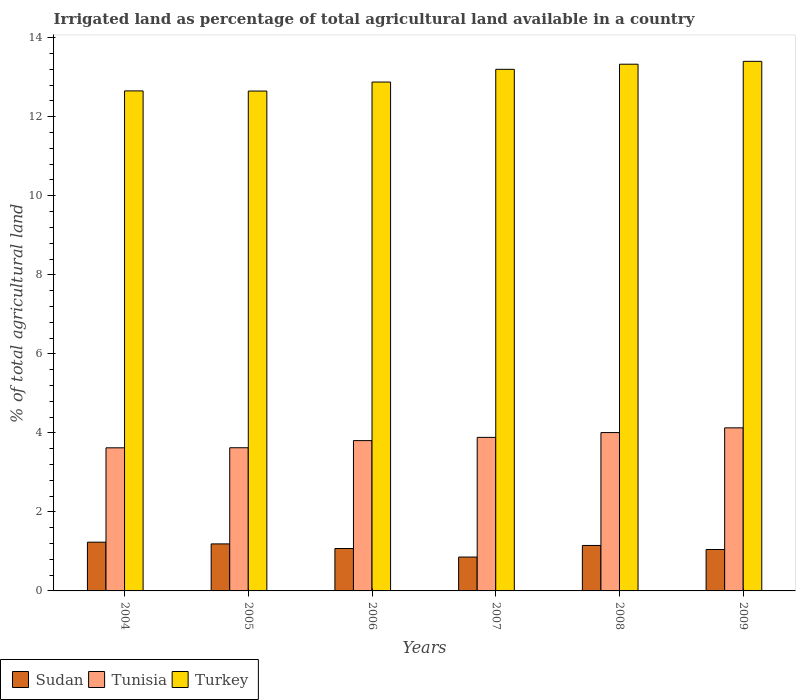How many groups of bars are there?
Give a very brief answer. 6. Are the number of bars per tick equal to the number of legend labels?
Your answer should be very brief. Yes. Are the number of bars on each tick of the X-axis equal?
Your answer should be very brief. Yes. How many bars are there on the 4th tick from the right?
Your answer should be compact. 3. What is the percentage of irrigated land in Tunisia in 2007?
Make the answer very short. 3.89. Across all years, what is the maximum percentage of irrigated land in Tunisia?
Provide a succinct answer. 4.13. Across all years, what is the minimum percentage of irrigated land in Tunisia?
Make the answer very short. 3.62. In which year was the percentage of irrigated land in Turkey maximum?
Ensure brevity in your answer.  2009. In which year was the percentage of irrigated land in Tunisia minimum?
Make the answer very short. 2004. What is the total percentage of irrigated land in Turkey in the graph?
Make the answer very short. 78.12. What is the difference between the percentage of irrigated land in Turkey in 2004 and that in 2007?
Give a very brief answer. -0.55. What is the difference between the percentage of irrigated land in Turkey in 2009 and the percentage of irrigated land in Sudan in 2006?
Keep it short and to the point. 12.33. What is the average percentage of irrigated land in Sudan per year?
Provide a short and direct response. 1.09. In the year 2006, what is the difference between the percentage of irrigated land in Turkey and percentage of irrigated land in Tunisia?
Give a very brief answer. 9.07. What is the ratio of the percentage of irrigated land in Turkey in 2005 to that in 2006?
Make the answer very short. 0.98. What is the difference between the highest and the second highest percentage of irrigated land in Tunisia?
Offer a terse response. 0.12. What is the difference between the highest and the lowest percentage of irrigated land in Tunisia?
Keep it short and to the point. 0.51. What does the 1st bar from the left in 2007 represents?
Give a very brief answer. Sudan. What does the 3rd bar from the right in 2004 represents?
Keep it short and to the point. Sudan. Is it the case that in every year, the sum of the percentage of irrigated land in Tunisia and percentage of irrigated land in Sudan is greater than the percentage of irrigated land in Turkey?
Your answer should be very brief. No. Are all the bars in the graph horizontal?
Give a very brief answer. No. How many years are there in the graph?
Give a very brief answer. 6. What is the difference between two consecutive major ticks on the Y-axis?
Keep it short and to the point. 2. Does the graph contain grids?
Provide a short and direct response. No. Where does the legend appear in the graph?
Keep it short and to the point. Bottom left. How many legend labels are there?
Ensure brevity in your answer.  3. How are the legend labels stacked?
Provide a succinct answer. Horizontal. What is the title of the graph?
Ensure brevity in your answer.  Irrigated land as percentage of total agricultural land available in a country. Does "Iraq" appear as one of the legend labels in the graph?
Offer a terse response. No. What is the label or title of the Y-axis?
Your response must be concise. % of total agricultural land. What is the % of total agricultural land in Sudan in 2004?
Ensure brevity in your answer.  1.23. What is the % of total agricultural land of Tunisia in 2004?
Keep it short and to the point. 3.62. What is the % of total agricultural land of Turkey in 2004?
Your answer should be compact. 12.65. What is the % of total agricultural land in Sudan in 2005?
Offer a very short reply. 1.19. What is the % of total agricultural land of Tunisia in 2005?
Your response must be concise. 3.62. What is the % of total agricultural land of Turkey in 2005?
Make the answer very short. 12.65. What is the % of total agricultural land of Sudan in 2006?
Keep it short and to the point. 1.07. What is the % of total agricultural land in Tunisia in 2006?
Your response must be concise. 3.8. What is the % of total agricultural land in Turkey in 2006?
Offer a very short reply. 12.88. What is the % of total agricultural land in Sudan in 2007?
Offer a very short reply. 0.86. What is the % of total agricultural land in Tunisia in 2007?
Your answer should be compact. 3.89. What is the % of total agricultural land in Turkey in 2007?
Your answer should be compact. 13.2. What is the % of total agricultural land in Sudan in 2008?
Your answer should be compact. 1.15. What is the % of total agricultural land of Tunisia in 2008?
Keep it short and to the point. 4.01. What is the % of total agricultural land in Turkey in 2008?
Provide a short and direct response. 13.33. What is the % of total agricultural land in Sudan in 2009?
Your response must be concise. 1.05. What is the % of total agricultural land of Tunisia in 2009?
Ensure brevity in your answer.  4.13. What is the % of total agricultural land of Turkey in 2009?
Offer a very short reply. 13.4. Across all years, what is the maximum % of total agricultural land in Sudan?
Your response must be concise. 1.23. Across all years, what is the maximum % of total agricultural land of Tunisia?
Keep it short and to the point. 4.13. Across all years, what is the maximum % of total agricultural land in Turkey?
Your answer should be very brief. 13.4. Across all years, what is the minimum % of total agricultural land in Sudan?
Provide a short and direct response. 0.86. Across all years, what is the minimum % of total agricultural land in Tunisia?
Make the answer very short. 3.62. Across all years, what is the minimum % of total agricultural land in Turkey?
Your response must be concise. 12.65. What is the total % of total agricultural land in Sudan in the graph?
Ensure brevity in your answer.  6.55. What is the total % of total agricultural land of Tunisia in the graph?
Give a very brief answer. 23.07. What is the total % of total agricultural land of Turkey in the graph?
Your answer should be compact. 78.12. What is the difference between the % of total agricultural land of Sudan in 2004 and that in 2005?
Your answer should be compact. 0.04. What is the difference between the % of total agricultural land in Tunisia in 2004 and that in 2005?
Make the answer very short. -0. What is the difference between the % of total agricultural land of Turkey in 2004 and that in 2005?
Offer a very short reply. 0. What is the difference between the % of total agricultural land in Sudan in 2004 and that in 2006?
Give a very brief answer. 0.16. What is the difference between the % of total agricultural land of Tunisia in 2004 and that in 2006?
Provide a succinct answer. -0.18. What is the difference between the % of total agricultural land of Turkey in 2004 and that in 2006?
Your response must be concise. -0.22. What is the difference between the % of total agricultural land in Sudan in 2004 and that in 2007?
Your answer should be compact. 0.38. What is the difference between the % of total agricultural land in Tunisia in 2004 and that in 2007?
Offer a very short reply. -0.26. What is the difference between the % of total agricultural land of Turkey in 2004 and that in 2007?
Provide a succinct answer. -0.55. What is the difference between the % of total agricultural land in Sudan in 2004 and that in 2008?
Make the answer very short. 0.08. What is the difference between the % of total agricultural land in Tunisia in 2004 and that in 2008?
Your answer should be very brief. -0.39. What is the difference between the % of total agricultural land of Turkey in 2004 and that in 2008?
Your answer should be compact. -0.68. What is the difference between the % of total agricultural land of Sudan in 2004 and that in 2009?
Give a very brief answer. 0.19. What is the difference between the % of total agricultural land in Tunisia in 2004 and that in 2009?
Make the answer very short. -0.51. What is the difference between the % of total agricultural land of Turkey in 2004 and that in 2009?
Your answer should be very brief. -0.75. What is the difference between the % of total agricultural land in Sudan in 2005 and that in 2006?
Your response must be concise. 0.12. What is the difference between the % of total agricultural land of Tunisia in 2005 and that in 2006?
Keep it short and to the point. -0.18. What is the difference between the % of total agricultural land of Turkey in 2005 and that in 2006?
Your answer should be compact. -0.23. What is the difference between the % of total agricultural land of Sudan in 2005 and that in 2007?
Your response must be concise. 0.33. What is the difference between the % of total agricultural land of Tunisia in 2005 and that in 2007?
Offer a terse response. -0.26. What is the difference between the % of total agricultural land in Turkey in 2005 and that in 2007?
Provide a short and direct response. -0.55. What is the difference between the % of total agricultural land of Sudan in 2005 and that in 2008?
Make the answer very short. 0.04. What is the difference between the % of total agricultural land of Tunisia in 2005 and that in 2008?
Ensure brevity in your answer.  -0.38. What is the difference between the % of total agricultural land of Turkey in 2005 and that in 2008?
Offer a very short reply. -0.68. What is the difference between the % of total agricultural land of Sudan in 2005 and that in 2009?
Your response must be concise. 0.14. What is the difference between the % of total agricultural land of Tunisia in 2005 and that in 2009?
Ensure brevity in your answer.  -0.5. What is the difference between the % of total agricultural land of Turkey in 2005 and that in 2009?
Offer a terse response. -0.75. What is the difference between the % of total agricultural land in Sudan in 2006 and that in 2007?
Your answer should be very brief. 0.22. What is the difference between the % of total agricultural land in Tunisia in 2006 and that in 2007?
Your answer should be very brief. -0.08. What is the difference between the % of total agricultural land in Turkey in 2006 and that in 2007?
Keep it short and to the point. -0.32. What is the difference between the % of total agricultural land in Sudan in 2006 and that in 2008?
Make the answer very short. -0.08. What is the difference between the % of total agricultural land of Tunisia in 2006 and that in 2008?
Give a very brief answer. -0.2. What is the difference between the % of total agricultural land of Turkey in 2006 and that in 2008?
Give a very brief answer. -0.45. What is the difference between the % of total agricultural land of Sudan in 2006 and that in 2009?
Give a very brief answer. 0.03. What is the difference between the % of total agricultural land in Tunisia in 2006 and that in 2009?
Give a very brief answer. -0.32. What is the difference between the % of total agricultural land of Turkey in 2006 and that in 2009?
Provide a short and direct response. -0.52. What is the difference between the % of total agricultural land in Sudan in 2007 and that in 2008?
Your response must be concise. -0.29. What is the difference between the % of total agricultural land in Tunisia in 2007 and that in 2008?
Give a very brief answer. -0.12. What is the difference between the % of total agricultural land of Turkey in 2007 and that in 2008?
Provide a short and direct response. -0.13. What is the difference between the % of total agricultural land in Sudan in 2007 and that in 2009?
Keep it short and to the point. -0.19. What is the difference between the % of total agricultural land in Tunisia in 2007 and that in 2009?
Your answer should be compact. -0.24. What is the difference between the % of total agricultural land in Turkey in 2007 and that in 2009?
Your answer should be compact. -0.2. What is the difference between the % of total agricultural land in Sudan in 2008 and that in 2009?
Provide a short and direct response. 0.1. What is the difference between the % of total agricultural land of Tunisia in 2008 and that in 2009?
Provide a succinct answer. -0.12. What is the difference between the % of total agricultural land of Turkey in 2008 and that in 2009?
Keep it short and to the point. -0.07. What is the difference between the % of total agricultural land in Sudan in 2004 and the % of total agricultural land in Tunisia in 2005?
Ensure brevity in your answer.  -2.39. What is the difference between the % of total agricultural land in Sudan in 2004 and the % of total agricultural land in Turkey in 2005?
Offer a terse response. -11.42. What is the difference between the % of total agricultural land of Tunisia in 2004 and the % of total agricultural land of Turkey in 2005?
Ensure brevity in your answer.  -9.03. What is the difference between the % of total agricultural land in Sudan in 2004 and the % of total agricultural land in Tunisia in 2006?
Your answer should be very brief. -2.57. What is the difference between the % of total agricultural land of Sudan in 2004 and the % of total agricultural land of Turkey in 2006?
Make the answer very short. -11.65. What is the difference between the % of total agricultural land in Tunisia in 2004 and the % of total agricultural land in Turkey in 2006?
Provide a short and direct response. -9.26. What is the difference between the % of total agricultural land of Sudan in 2004 and the % of total agricultural land of Tunisia in 2007?
Offer a terse response. -2.65. What is the difference between the % of total agricultural land in Sudan in 2004 and the % of total agricultural land in Turkey in 2007?
Provide a succinct answer. -11.97. What is the difference between the % of total agricultural land of Tunisia in 2004 and the % of total agricultural land of Turkey in 2007?
Give a very brief answer. -9.58. What is the difference between the % of total agricultural land in Sudan in 2004 and the % of total agricultural land in Tunisia in 2008?
Offer a very short reply. -2.77. What is the difference between the % of total agricultural land of Sudan in 2004 and the % of total agricultural land of Turkey in 2008?
Your answer should be very brief. -12.1. What is the difference between the % of total agricultural land in Tunisia in 2004 and the % of total agricultural land in Turkey in 2008?
Provide a short and direct response. -9.71. What is the difference between the % of total agricultural land of Sudan in 2004 and the % of total agricultural land of Tunisia in 2009?
Keep it short and to the point. -2.89. What is the difference between the % of total agricultural land of Sudan in 2004 and the % of total agricultural land of Turkey in 2009?
Your response must be concise. -12.17. What is the difference between the % of total agricultural land of Tunisia in 2004 and the % of total agricultural land of Turkey in 2009?
Your answer should be compact. -9.78. What is the difference between the % of total agricultural land in Sudan in 2005 and the % of total agricultural land in Tunisia in 2006?
Your response must be concise. -2.61. What is the difference between the % of total agricultural land of Sudan in 2005 and the % of total agricultural land of Turkey in 2006?
Offer a terse response. -11.69. What is the difference between the % of total agricultural land of Tunisia in 2005 and the % of total agricultural land of Turkey in 2006?
Offer a very short reply. -9.26. What is the difference between the % of total agricultural land of Sudan in 2005 and the % of total agricultural land of Tunisia in 2007?
Provide a short and direct response. -2.7. What is the difference between the % of total agricultural land of Sudan in 2005 and the % of total agricultural land of Turkey in 2007?
Make the answer very short. -12.01. What is the difference between the % of total agricultural land of Tunisia in 2005 and the % of total agricultural land of Turkey in 2007?
Provide a short and direct response. -9.58. What is the difference between the % of total agricultural land in Sudan in 2005 and the % of total agricultural land in Tunisia in 2008?
Offer a very short reply. -2.82. What is the difference between the % of total agricultural land of Sudan in 2005 and the % of total agricultural land of Turkey in 2008?
Make the answer very short. -12.14. What is the difference between the % of total agricultural land of Tunisia in 2005 and the % of total agricultural land of Turkey in 2008?
Provide a short and direct response. -9.71. What is the difference between the % of total agricultural land in Sudan in 2005 and the % of total agricultural land in Tunisia in 2009?
Give a very brief answer. -2.94. What is the difference between the % of total agricultural land of Sudan in 2005 and the % of total agricultural land of Turkey in 2009?
Offer a terse response. -12.21. What is the difference between the % of total agricultural land in Tunisia in 2005 and the % of total agricultural land in Turkey in 2009?
Ensure brevity in your answer.  -9.78. What is the difference between the % of total agricultural land of Sudan in 2006 and the % of total agricultural land of Tunisia in 2007?
Make the answer very short. -2.81. What is the difference between the % of total agricultural land of Sudan in 2006 and the % of total agricultural land of Turkey in 2007?
Make the answer very short. -12.13. What is the difference between the % of total agricultural land of Tunisia in 2006 and the % of total agricultural land of Turkey in 2007?
Offer a terse response. -9.4. What is the difference between the % of total agricultural land of Sudan in 2006 and the % of total agricultural land of Tunisia in 2008?
Provide a short and direct response. -2.93. What is the difference between the % of total agricultural land in Sudan in 2006 and the % of total agricultural land in Turkey in 2008?
Make the answer very short. -12.26. What is the difference between the % of total agricultural land in Tunisia in 2006 and the % of total agricultural land in Turkey in 2008?
Your response must be concise. -9.53. What is the difference between the % of total agricultural land of Sudan in 2006 and the % of total agricultural land of Tunisia in 2009?
Offer a terse response. -3.05. What is the difference between the % of total agricultural land in Sudan in 2006 and the % of total agricultural land in Turkey in 2009?
Make the answer very short. -12.33. What is the difference between the % of total agricultural land of Tunisia in 2006 and the % of total agricultural land of Turkey in 2009?
Your answer should be compact. -9.6. What is the difference between the % of total agricultural land of Sudan in 2007 and the % of total agricultural land of Tunisia in 2008?
Provide a short and direct response. -3.15. What is the difference between the % of total agricultural land of Sudan in 2007 and the % of total agricultural land of Turkey in 2008?
Your response must be concise. -12.47. What is the difference between the % of total agricultural land of Tunisia in 2007 and the % of total agricultural land of Turkey in 2008?
Give a very brief answer. -9.44. What is the difference between the % of total agricultural land in Sudan in 2007 and the % of total agricultural land in Tunisia in 2009?
Give a very brief answer. -3.27. What is the difference between the % of total agricultural land of Sudan in 2007 and the % of total agricultural land of Turkey in 2009?
Your response must be concise. -12.55. What is the difference between the % of total agricultural land in Tunisia in 2007 and the % of total agricultural land in Turkey in 2009?
Keep it short and to the point. -9.52. What is the difference between the % of total agricultural land in Sudan in 2008 and the % of total agricultural land in Tunisia in 2009?
Your answer should be very brief. -2.98. What is the difference between the % of total agricultural land of Sudan in 2008 and the % of total agricultural land of Turkey in 2009?
Make the answer very short. -12.25. What is the difference between the % of total agricultural land of Tunisia in 2008 and the % of total agricultural land of Turkey in 2009?
Keep it short and to the point. -9.39. What is the average % of total agricultural land in Sudan per year?
Offer a terse response. 1.09. What is the average % of total agricultural land in Tunisia per year?
Your response must be concise. 3.84. What is the average % of total agricultural land of Turkey per year?
Make the answer very short. 13.02. In the year 2004, what is the difference between the % of total agricultural land of Sudan and % of total agricultural land of Tunisia?
Make the answer very short. -2.39. In the year 2004, what is the difference between the % of total agricultural land in Sudan and % of total agricultural land in Turkey?
Make the answer very short. -11.42. In the year 2004, what is the difference between the % of total agricultural land of Tunisia and % of total agricultural land of Turkey?
Provide a short and direct response. -9.03. In the year 2005, what is the difference between the % of total agricultural land of Sudan and % of total agricultural land of Tunisia?
Keep it short and to the point. -2.43. In the year 2005, what is the difference between the % of total agricultural land of Sudan and % of total agricultural land of Turkey?
Provide a short and direct response. -11.46. In the year 2005, what is the difference between the % of total agricultural land of Tunisia and % of total agricultural land of Turkey?
Offer a terse response. -9.03. In the year 2006, what is the difference between the % of total agricultural land in Sudan and % of total agricultural land in Tunisia?
Your answer should be very brief. -2.73. In the year 2006, what is the difference between the % of total agricultural land of Sudan and % of total agricultural land of Turkey?
Your response must be concise. -11.81. In the year 2006, what is the difference between the % of total agricultural land of Tunisia and % of total agricultural land of Turkey?
Make the answer very short. -9.07. In the year 2007, what is the difference between the % of total agricultural land of Sudan and % of total agricultural land of Tunisia?
Your answer should be compact. -3.03. In the year 2007, what is the difference between the % of total agricultural land in Sudan and % of total agricultural land in Turkey?
Provide a short and direct response. -12.34. In the year 2007, what is the difference between the % of total agricultural land of Tunisia and % of total agricultural land of Turkey?
Your answer should be very brief. -9.32. In the year 2008, what is the difference between the % of total agricultural land in Sudan and % of total agricultural land in Tunisia?
Offer a terse response. -2.86. In the year 2008, what is the difference between the % of total agricultural land of Sudan and % of total agricultural land of Turkey?
Ensure brevity in your answer.  -12.18. In the year 2008, what is the difference between the % of total agricultural land in Tunisia and % of total agricultural land in Turkey?
Your answer should be very brief. -9.32. In the year 2009, what is the difference between the % of total agricultural land of Sudan and % of total agricultural land of Tunisia?
Offer a very short reply. -3.08. In the year 2009, what is the difference between the % of total agricultural land of Sudan and % of total agricultural land of Turkey?
Your response must be concise. -12.35. In the year 2009, what is the difference between the % of total agricultural land of Tunisia and % of total agricultural land of Turkey?
Provide a short and direct response. -9.28. What is the ratio of the % of total agricultural land of Sudan in 2004 to that in 2005?
Your answer should be compact. 1.04. What is the ratio of the % of total agricultural land of Tunisia in 2004 to that in 2005?
Give a very brief answer. 1. What is the ratio of the % of total agricultural land of Turkey in 2004 to that in 2005?
Provide a succinct answer. 1. What is the ratio of the % of total agricultural land of Sudan in 2004 to that in 2006?
Your answer should be very brief. 1.15. What is the ratio of the % of total agricultural land in Tunisia in 2004 to that in 2006?
Keep it short and to the point. 0.95. What is the ratio of the % of total agricultural land in Turkey in 2004 to that in 2006?
Provide a short and direct response. 0.98. What is the ratio of the % of total agricultural land in Sudan in 2004 to that in 2007?
Your answer should be very brief. 1.44. What is the ratio of the % of total agricultural land in Tunisia in 2004 to that in 2007?
Ensure brevity in your answer.  0.93. What is the ratio of the % of total agricultural land in Turkey in 2004 to that in 2007?
Offer a terse response. 0.96. What is the ratio of the % of total agricultural land in Sudan in 2004 to that in 2008?
Offer a very short reply. 1.07. What is the ratio of the % of total agricultural land of Tunisia in 2004 to that in 2008?
Ensure brevity in your answer.  0.9. What is the ratio of the % of total agricultural land of Turkey in 2004 to that in 2008?
Give a very brief answer. 0.95. What is the ratio of the % of total agricultural land of Sudan in 2004 to that in 2009?
Provide a short and direct response. 1.18. What is the ratio of the % of total agricultural land of Tunisia in 2004 to that in 2009?
Your answer should be compact. 0.88. What is the ratio of the % of total agricultural land in Turkey in 2004 to that in 2009?
Provide a succinct answer. 0.94. What is the ratio of the % of total agricultural land in Sudan in 2005 to that in 2006?
Your answer should be very brief. 1.11. What is the ratio of the % of total agricultural land of Tunisia in 2005 to that in 2006?
Keep it short and to the point. 0.95. What is the ratio of the % of total agricultural land in Turkey in 2005 to that in 2006?
Offer a terse response. 0.98. What is the ratio of the % of total agricultural land in Sudan in 2005 to that in 2007?
Your answer should be very brief. 1.39. What is the ratio of the % of total agricultural land of Tunisia in 2005 to that in 2007?
Ensure brevity in your answer.  0.93. What is the ratio of the % of total agricultural land in Sudan in 2005 to that in 2008?
Ensure brevity in your answer.  1.03. What is the ratio of the % of total agricultural land in Tunisia in 2005 to that in 2008?
Provide a succinct answer. 0.9. What is the ratio of the % of total agricultural land of Turkey in 2005 to that in 2008?
Give a very brief answer. 0.95. What is the ratio of the % of total agricultural land in Sudan in 2005 to that in 2009?
Your answer should be compact. 1.14. What is the ratio of the % of total agricultural land of Tunisia in 2005 to that in 2009?
Provide a succinct answer. 0.88. What is the ratio of the % of total agricultural land in Turkey in 2005 to that in 2009?
Your answer should be very brief. 0.94. What is the ratio of the % of total agricultural land of Sudan in 2006 to that in 2007?
Offer a terse response. 1.25. What is the ratio of the % of total agricultural land of Tunisia in 2006 to that in 2007?
Offer a terse response. 0.98. What is the ratio of the % of total agricultural land of Turkey in 2006 to that in 2007?
Your answer should be compact. 0.98. What is the ratio of the % of total agricultural land of Sudan in 2006 to that in 2008?
Your answer should be very brief. 0.93. What is the ratio of the % of total agricultural land of Tunisia in 2006 to that in 2008?
Provide a succinct answer. 0.95. What is the ratio of the % of total agricultural land in Turkey in 2006 to that in 2008?
Your answer should be compact. 0.97. What is the ratio of the % of total agricultural land in Sudan in 2006 to that in 2009?
Make the answer very short. 1.02. What is the ratio of the % of total agricultural land in Tunisia in 2006 to that in 2009?
Your answer should be compact. 0.92. What is the ratio of the % of total agricultural land in Turkey in 2006 to that in 2009?
Your answer should be very brief. 0.96. What is the ratio of the % of total agricultural land of Sudan in 2007 to that in 2008?
Ensure brevity in your answer.  0.74. What is the ratio of the % of total agricultural land of Tunisia in 2007 to that in 2008?
Give a very brief answer. 0.97. What is the ratio of the % of total agricultural land of Turkey in 2007 to that in 2008?
Make the answer very short. 0.99. What is the ratio of the % of total agricultural land in Sudan in 2007 to that in 2009?
Ensure brevity in your answer.  0.82. What is the ratio of the % of total agricultural land of Tunisia in 2007 to that in 2009?
Ensure brevity in your answer.  0.94. What is the ratio of the % of total agricultural land in Turkey in 2007 to that in 2009?
Your answer should be very brief. 0.98. What is the ratio of the % of total agricultural land of Sudan in 2008 to that in 2009?
Your answer should be very brief. 1.1. What is the ratio of the % of total agricultural land in Tunisia in 2008 to that in 2009?
Give a very brief answer. 0.97. What is the difference between the highest and the second highest % of total agricultural land of Sudan?
Your answer should be very brief. 0.04. What is the difference between the highest and the second highest % of total agricultural land in Tunisia?
Ensure brevity in your answer.  0.12. What is the difference between the highest and the second highest % of total agricultural land of Turkey?
Provide a short and direct response. 0.07. What is the difference between the highest and the lowest % of total agricultural land in Sudan?
Your answer should be very brief. 0.38. What is the difference between the highest and the lowest % of total agricultural land in Tunisia?
Your response must be concise. 0.51. What is the difference between the highest and the lowest % of total agricultural land of Turkey?
Offer a very short reply. 0.75. 